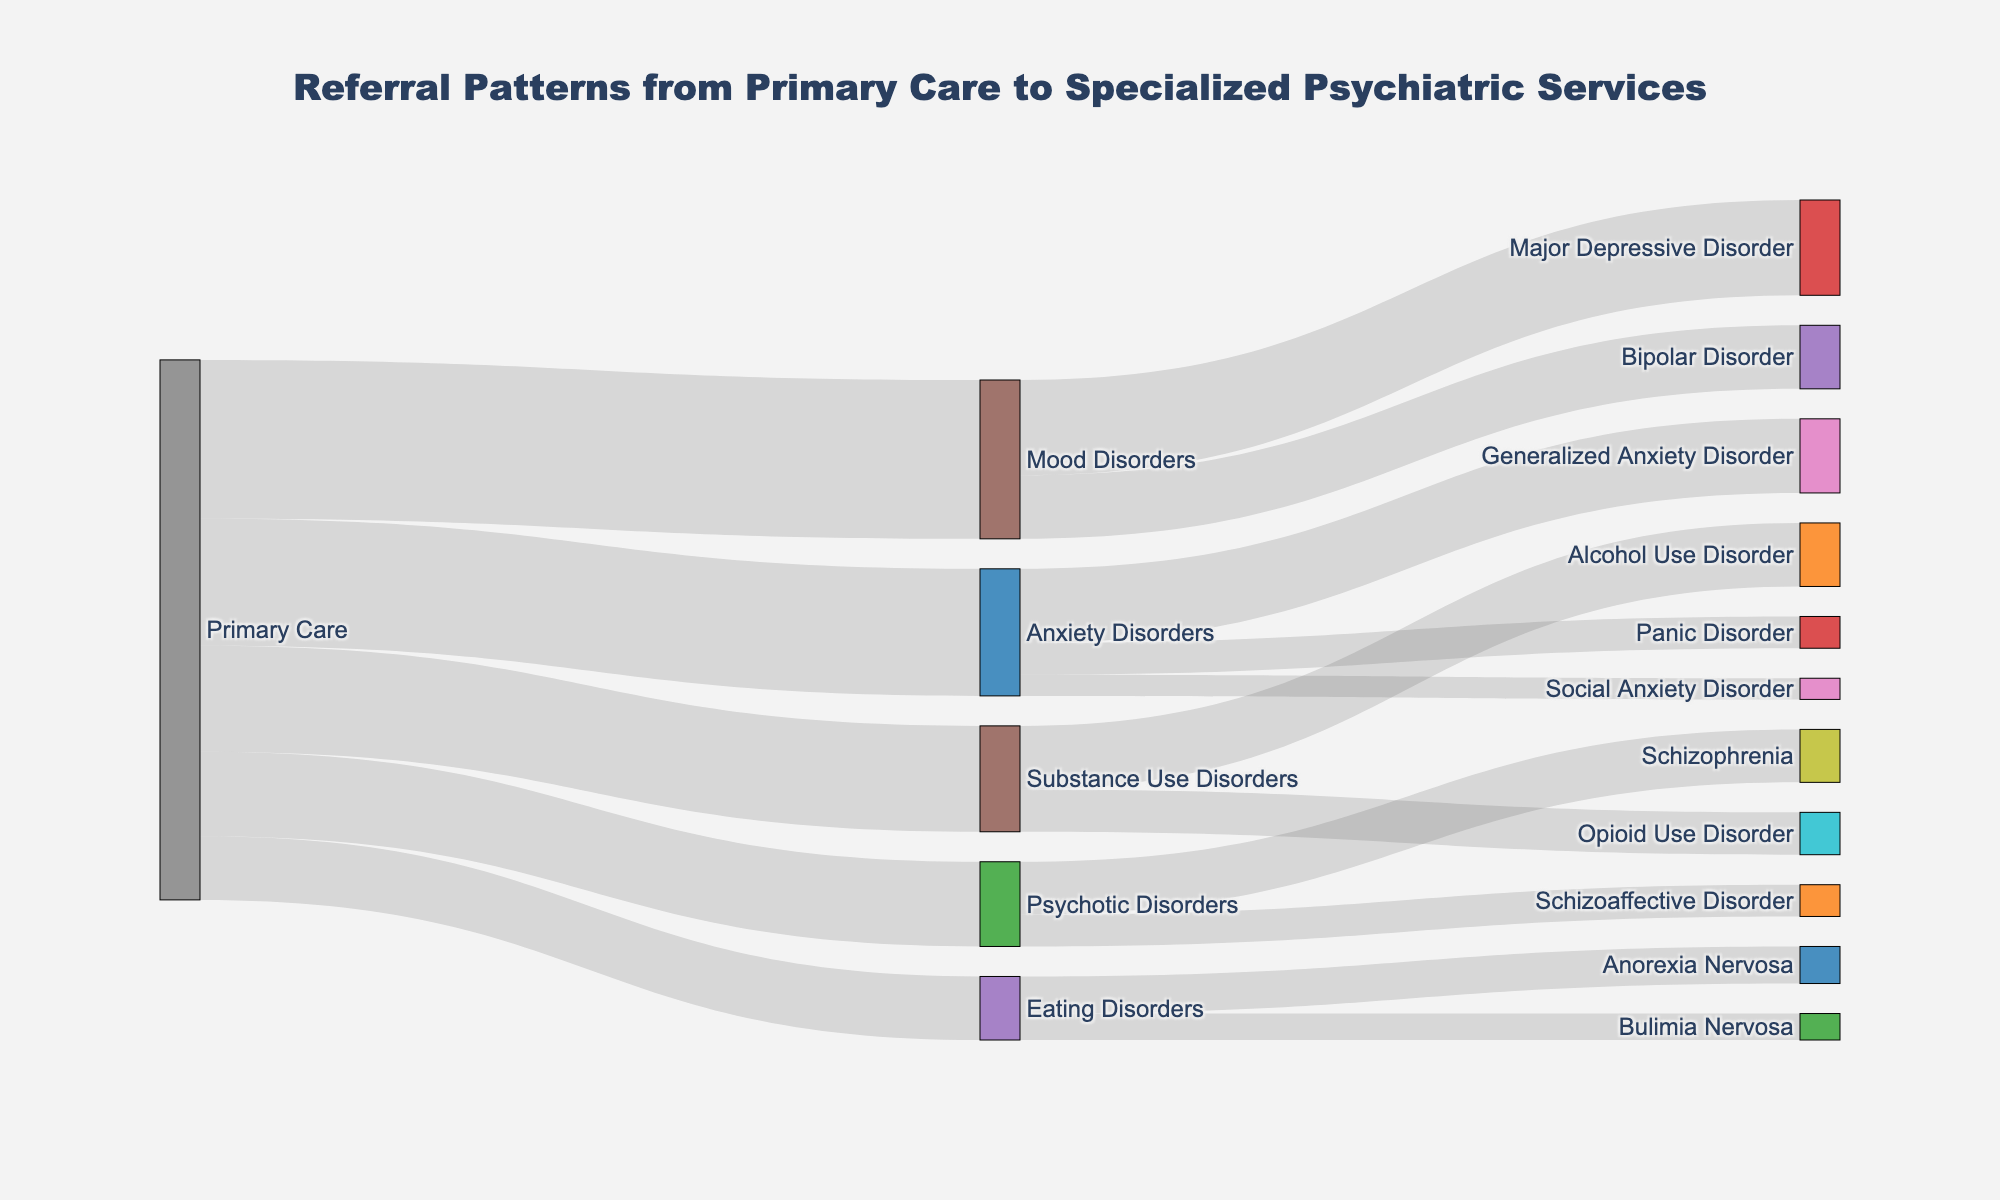What is the title of the figure? The title of the figure is positioned at the top center of the diagram and provides a summary of what the data represents.
Answer: Referral Patterns from Primary Care to Specialized Psychiatric Services Which specialized psychiatric service receives the highest number of referrals from primary care? By examining the links from "Primary Care," the width of the link corresponding to each service indicates the number of referrals. The widest link ends at "Mood Disorders."
Answer: Mood Disorders How many patients were referred from primary care to have Generalized Anxiety Disorder? Starting from "Primary Care," follow the link to "Anxiety Disorders" and then to "Generalized Anxiety Disorder." The number beside the final link is the value.
Answer: 70 Compare the number of referrals for Substance Use Disorders and Eating Disorders. Which one has more, and by how much? Look at the links from "Primary Care" to "Substance Use Disorders" and "Eating Disorders." The values for Substance Use Disorders and Eating Disorders are 100 and 60, respectively. The difference is 100 - 60.
Answer: Substance Use Disorders by 40 What is the total number of referrals for Anxiety Disorders? The total number of referrals for Anxiety Disorders is the sum of referrals for Generalized Anxiety Disorder, Panic Disorder, and Social Anxiety Disorder. The values are 70, 30, and 20, respectively. Sum these values: 70 + 30 + 20 = 120.
Answer: 120 Which specific disorder under Mood Disorders has the highest number of referrals? Follow the links from "Mood Disorders" to its specific disorders. Compare the values for Major Depressive Disorder and Bipolar Disorder. The largest number is for Major Depressive Disorder.
Answer: Major Depressive Disorder How many more patients were referred for Major Depressive Disorder compared to Bipolar Disorder? Identify the referral numbers for Major Depressive Disorder (90) and Bipolar Disorder (60). Subtract the smaller number from the larger one: 90 - 60.
Answer: 30 What is the total number of referrals from primary care for all disorders combined? Sum all values originating from "Primary Care:" 120 (Anxiety) + 150 (Mood) + 80 (Psychotic) + 100 (Substance Use) + 60 (Eating) = 510.
Answer: 510 Which specific disorder under Psychotic Disorders has fewer referrals? Compare the referral numbers for Schizophrenia and Schizoaffective Disorder. Schizoaffective Disorder has the smaller value.
Answer: Schizoaffective Disorder Determine the combined number of referrals for Schizophrenia and Alcohol Use Disorder. Add the numbers for Schizophrenia (50) and Alcohol Use Disorder (60): 50 + 60.
Answer: 110 